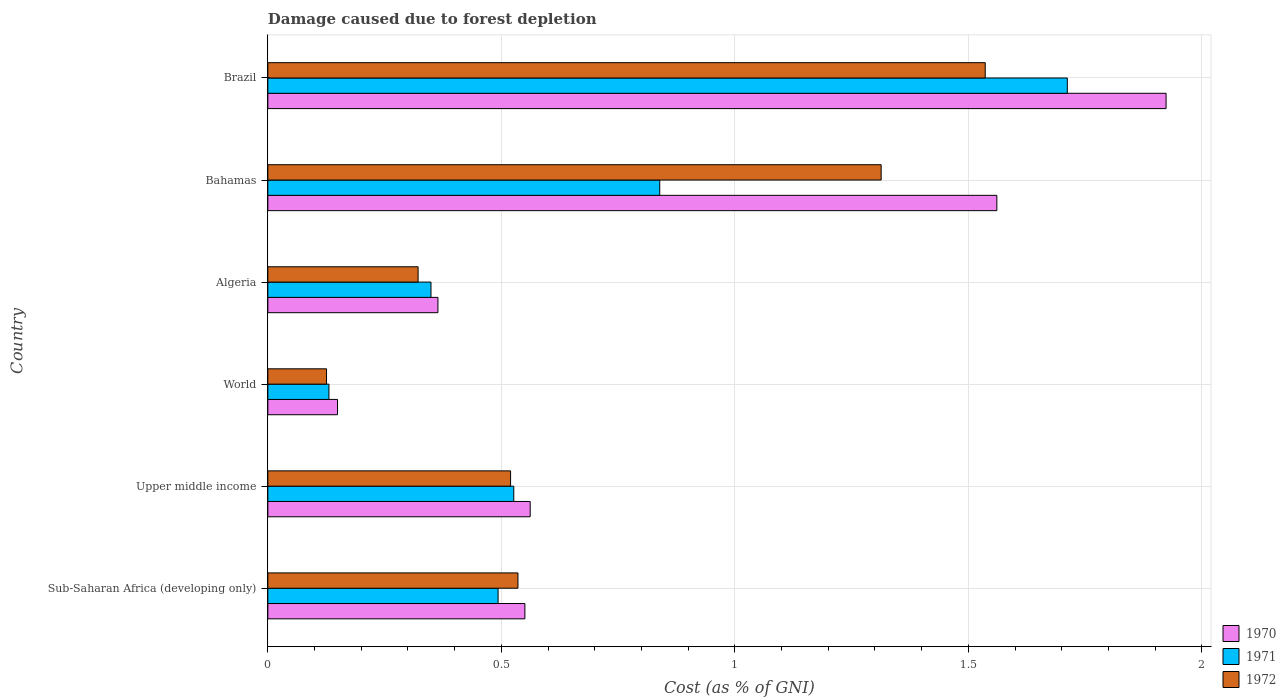Are the number of bars per tick equal to the number of legend labels?
Offer a very short reply. Yes. Are the number of bars on each tick of the Y-axis equal?
Keep it short and to the point. Yes. What is the label of the 5th group of bars from the top?
Ensure brevity in your answer.  Upper middle income. What is the cost of damage caused due to forest depletion in 1970 in Algeria?
Provide a short and direct response. 0.36. Across all countries, what is the maximum cost of damage caused due to forest depletion in 1970?
Give a very brief answer. 1.92. Across all countries, what is the minimum cost of damage caused due to forest depletion in 1972?
Offer a terse response. 0.13. In which country was the cost of damage caused due to forest depletion in 1971 minimum?
Offer a terse response. World. What is the total cost of damage caused due to forest depletion in 1971 in the graph?
Make the answer very short. 4.05. What is the difference between the cost of damage caused due to forest depletion in 1970 in Algeria and that in World?
Your answer should be very brief. 0.21. What is the difference between the cost of damage caused due to forest depletion in 1970 in Algeria and the cost of damage caused due to forest depletion in 1971 in Brazil?
Provide a succinct answer. -1.35. What is the average cost of damage caused due to forest depletion in 1970 per country?
Keep it short and to the point. 0.85. What is the difference between the cost of damage caused due to forest depletion in 1972 and cost of damage caused due to forest depletion in 1970 in Algeria?
Provide a short and direct response. -0.04. What is the ratio of the cost of damage caused due to forest depletion in 1970 in Bahamas to that in Sub-Saharan Africa (developing only)?
Offer a very short reply. 2.84. What is the difference between the highest and the second highest cost of damage caused due to forest depletion in 1972?
Your answer should be compact. 0.22. What is the difference between the highest and the lowest cost of damage caused due to forest depletion in 1972?
Your response must be concise. 1.41. In how many countries, is the cost of damage caused due to forest depletion in 1971 greater than the average cost of damage caused due to forest depletion in 1971 taken over all countries?
Your response must be concise. 2. What does the 1st bar from the top in World represents?
Your response must be concise. 1972. What does the 1st bar from the bottom in Sub-Saharan Africa (developing only) represents?
Offer a very short reply. 1970. How many countries are there in the graph?
Make the answer very short. 6. Does the graph contain grids?
Give a very brief answer. Yes. Where does the legend appear in the graph?
Offer a very short reply. Bottom right. How many legend labels are there?
Offer a terse response. 3. How are the legend labels stacked?
Keep it short and to the point. Vertical. What is the title of the graph?
Your answer should be very brief. Damage caused due to forest depletion. Does "2010" appear as one of the legend labels in the graph?
Provide a succinct answer. No. What is the label or title of the X-axis?
Offer a terse response. Cost (as % of GNI). What is the label or title of the Y-axis?
Offer a very short reply. Country. What is the Cost (as % of GNI) in 1970 in Sub-Saharan Africa (developing only)?
Your response must be concise. 0.55. What is the Cost (as % of GNI) of 1971 in Sub-Saharan Africa (developing only)?
Your answer should be compact. 0.49. What is the Cost (as % of GNI) in 1972 in Sub-Saharan Africa (developing only)?
Offer a very short reply. 0.54. What is the Cost (as % of GNI) of 1970 in Upper middle income?
Your answer should be compact. 0.56. What is the Cost (as % of GNI) of 1971 in Upper middle income?
Give a very brief answer. 0.53. What is the Cost (as % of GNI) in 1972 in Upper middle income?
Provide a short and direct response. 0.52. What is the Cost (as % of GNI) of 1970 in World?
Provide a short and direct response. 0.15. What is the Cost (as % of GNI) of 1971 in World?
Offer a terse response. 0.13. What is the Cost (as % of GNI) in 1972 in World?
Keep it short and to the point. 0.13. What is the Cost (as % of GNI) of 1970 in Algeria?
Offer a terse response. 0.36. What is the Cost (as % of GNI) of 1971 in Algeria?
Give a very brief answer. 0.35. What is the Cost (as % of GNI) of 1972 in Algeria?
Keep it short and to the point. 0.32. What is the Cost (as % of GNI) in 1970 in Bahamas?
Your response must be concise. 1.56. What is the Cost (as % of GNI) in 1971 in Bahamas?
Provide a short and direct response. 0.84. What is the Cost (as % of GNI) of 1972 in Bahamas?
Give a very brief answer. 1.31. What is the Cost (as % of GNI) of 1970 in Brazil?
Your answer should be compact. 1.92. What is the Cost (as % of GNI) in 1971 in Brazil?
Your answer should be compact. 1.71. What is the Cost (as % of GNI) in 1972 in Brazil?
Offer a terse response. 1.54. Across all countries, what is the maximum Cost (as % of GNI) in 1970?
Provide a succinct answer. 1.92. Across all countries, what is the maximum Cost (as % of GNI) in 1971?
Your answer should be very brief. 1.71. Across all countries, what is the maximum Cost (as % of GNI) in 1972?
Your response must be concise. 1.54. Across all countries, what is the minimum Cost (as % of GNI) in 1970?
Offer a very short reply. 0.15. Across all countries, what is the minimum Cost (as % of GNI) of 1971?
Make the answer very short. 0.13. Across all countries, what is the minimum Cost (as % of GNI) of 1972?
Your answer should be compact. 0.13. What is the total Cost (as % of GNI) in 1970 in the graph?
Offer a terse response. 5.11. What is the total Cost (as % of GNI) of 1971 in the graph?
Ensure brevity in your answer.  4.05. What is the total Cost (as % of GNI) in 1972 in the graph?
Offer a terse response. 4.35. What is the difference between the Cost (as % of GNI) of 1970 in Sub-Saharan Africa (developing only) and that in Upper middle income?
Give a very brief answer. -0.01. What is the difference between the Cost (as % of GNI) of 1971 in Sub-Saharan Africa (developing only) and that in Upper middle income?
Offer a very short reply. -0.03. What is the difference between the Cost (as % of GNI) in 1972 in Sub-Saharan Africa (developing only) and that in Upper middle income?
Offer a very short reply. 0.02. What is the difference between the Cost (as % of GNI) in 1970 in Sub-Saharan Africa (developing only) and that in World?
Provide a succinct answer. 0.4. What is the difference between the Cost (as % of GNI) in 1971 in Sub-Saharan Africa (developing only) and that in World?
Your answer should be compact. 0.36. What is the difference between the Cost (as % of GNI) of 1972 in Sub-Saharan Africa (developing only) and that in World?
Give a very brief answer. 0.41. What is the difference between the Cost (as % of GNI) of 1970 in Sub-Saharan Africa (developing only) and that in Algeria?
Offer a very short reply. 0.19. What is the difference between the Cost (as % of GNI) of 1971 in Sub-Saharan Africa (developing only) and that in Algeria?
Your answer should be compact. 0.14. What is the difference between the Cost (as % of GNI) in 1972 in Sub-Saharan Africa (developing only) and that in Algeria?
Make the answer very short. 0.21. What is the difference between the Cost (as % of GNI) in 1970 in Sub-Saharan Africa (developing only) and that in Bahamas?
Offer a very short reply. -1.01. What is the difference between the Cost (as % of GNI) of 1971 in Sub-Saharan Africa (developing only) and that in Bahamas?
Keep it short and to the point. -0.35. What is the difference between the Cost (as % of GNI) of 1972 in Sub-Saharan Africa (developing only) and that in Bahamas?
Make the answer very short. -0.78. What is the difference between the Cost (as % of GNI) of 1970 in Sub-Saharan Africa (developing only) and that in Brazil?
Ensure brevity in your answer.  -1.37. What is the difference between the Cost (as % of GNI) in 1971 in Sub-Saharan Africa (developing only) and that in Brazil?
Offer a very short reply. -1.22. What is the difference between the Cost (as % of GNI) of 1972 in Sub-Saharan Africa (developing only) and that in Brazil?
Keep it short and to the point. -1. What is the difference between the Cost (as % of GNI) of 1970 in Upper middle income and that in World?
Keep it short and to the point. 0.41. What is the difference between the Cost (as % of GNI) of 1971 in Upper middle income and that in World?
Offer a very short reply. 0.4. What is the difference between the Cost (as % of GNI) in 1972 in Upper middle income and that in World?
Keep it short and to the point. 0.39. What is the difference between the Cost (as % of GNI) of 1970 in Upper middle income and that in Algeria?
Ensure brevity in your answer.  0.2. What is the difference between the Cost (as % of GNI) of 1971 in Upper middle income and that in Algeria?
Offer a terse response. 0.18. What is the difference between the Cost (as % of GNI) of 1972 in Upper middle income and that in Algeria?
Give a very brief answer. 0.2. What is the difference between the Cost (as % of GNI) of 1970 in Upper middle income and that in Bahamas?
Keep it short and to the point. -1. What is the difference between the Cost (as % of GNI) in 1971 in Upper middle income and that in Bahamas?
Give a very brief answer. -0.31. What is the difference between the Cost (as % of GNI) of 1972 in Upper middle income and that in Bahamas?
Keep it short and to the point. -0.79. What is the difference between the Cost (as % of GNI) in 1970 in Upper middle income and that in Brazil?
Offer a very short reply. -1.36. What is the difference between the Cost (as % of GNI) in 1971 in Upper middle income and that in Brazil?
Provide a succinct answer. -1.19. What is the difference between the Cost (as % of GNI) in 1972 in Upper middle income and that in Brazil?
Provide a succinct answer. -1.02. What is the difference between the Cost (as % of GNI) in 1970 in World and that in Algeria?
Make the answer very short. -0.21. What is the difference between the Cost (as % of GNI) of 1971 in World and that in Algeria?
Your response must be concise. -0.22. What is the difference between the Cost (as % of GNI) of 1972 in World and that in Algeria?
Your answer should be compact. -0.2. What is the difference between the Cost (as % of GNI) of 1970 in World and that in Bahamas?
Make the answer very short. -1.41. What is the difference between the Cost (as % of GNI) in 1971 in World and that in Bahamas?
Make the answer very short. -0.71. What is the difference between the Cost (as % of GNI) of 1972 in World and that in Bahamas?
Offer a terse response. -1.19. What is the difference between the Cost (as % of GNI) of 1970 in World and that in Brazil?
Keep it short and to the point. -1.77. What is the difference between the Cost (as % of GNI) of 1971 in World and that in Brazil?
Give a very brief answer. -1.58. What is the difference between the Cost (as % of GNI) in 1972 in World and that in Brazil?
Ensure brevity in your answer.  -1.41. What is the difference between the Cost (as % of GNI) in 1970 in Algeria and that in Bahamas?
Your response must be concise. -1.2. What is the difference between the Cost (as % of GNI) of 1971 in Algeria and that in Bahamas?
Give a very brief answer. -0.49. What is the difference between the Cost (as % of GNI) in 1972 in Algeria and that in Bahamas?
Offer a terse response. -0.99. What is the difference between the Cost (as % of GNI) of 1970 in Algeria and that in Brazil?
Provide a succinct answer. -1.56. What is the difference between the Cost (as % of GNI) in 1971 in Algeria and that in Brazil?
Keep it short and to the point. -1.36. What is the difference between the Cost (as % of GNI) in 1972 in Algeria and that in Brazil?
Give a very brief answer. -1.21. What is the difference between the Cost (as % of GNI) in 1970 in Bahamas and that in Brazil?
Your answer should be compact. -0.36. What is the difference between the Cost (as % of GNI) in 1971 in Bahamas and that in Brazil?
Offer a terse response. -0.87. What is the difference between the Cost (as % of GNI) of 1972 in Bahamas and that in Brazil?
Give a very brief answer. -0.22. What is the difference between the Cost (as % of GNI) of 1970 in Sub-Saharan Africa (developing only) and the Cost (as % of GNI) of 1971 in Upper middle income?
Your answer should be very brief. 0.02. What is the difference between the Cost (as % of GNI) in 1970 in Sub-Saharan Africa (developing only) and the Cost (as % of GNI) in 1972 in Upper middle income?
Offer a terse response. 0.03. What is the difference between the Cost (as % of GNI) in 1971 in Sub-Saharan Africa (developing only) and the Cost (as % of GNI) in 1972 in Upper middle income?
Make the answer very short. -0.03. What is the difference between the Cost (as % of GNI) in 1970 in Sub-Saharan Africa (developing only) and the Cost (as % of GNI) in 1971 in World?
Ensure brevity in your answer.  0.42. What is the difference between the Cost (as % of GNI) in 1970 in Sub-Saharan Africa (developing only) and the Cost (as % of GNI) in 1972 in World?
Offer a terse response. 0.42. What is the difference between the Cost (as % of GNI) of 1971 in Sub-Saharan Africa (developing only) and the Cost (as % of GNI) of 1972 in World?
Ensure brevity in your answer.  0.37. What is the difference between the Cost (as % of GNI) of 1970 in Sub-Saharan Africa (developing only) and the Cost (as % of GNI) of 1971 in Algeria?
Keep it short and to the point. 0.2. What is the difference between the Cost (as % of GNI) in 1970 in Sub-Saharan Africa (developing only) and the Cost (as % of GNI) in 1972 in Algeria?
Your response must be concise. 0.23. What is the difference between the Cost (as % of GNI) of 1971 in Sub-Saharan Africa (developing only) and the Cost (as % of GNI) of 1972 in Algeria?
Provide a succinct answer. 0.17. What is the difference between the Cost (as % of GNI) of 1970 in Sub-Saharan Africa (developing only) and the Cost (as % of GNI) of 1971 in Bahamas?
Your answer should be very brief. -0.29. What is the difference between the Cost (as % of GNI) of 1970 in Sub-Saharan Africa (developing only) and the Cost (as % of GNI) of 1972 in Bahamas?
Make the answer very short. -0.76. What is the difference between the Cost (as % of GNI) of 1971 in Sub-Saharan Africa (developing only) and the Cost (as % of GNI) of 1972 in Bahamas?
Make the answer very short. -0.82. What is the difference between the Cost (as % of GNI) in 1970 in Sub-Saharan Africa (developing only) and the Cost (as % of GNI) in 1971 in Brazil?
Make the answer very short. -1.16. What is the difference between the Cost (as % of GNI) of 1970 in Sub-Saharan Africa (developing only) and the Cost (as % of GNI) of 1972 in Brazil?
Make the answer very short. -0.99. What is the difference between the Cost (as % of GNI) of 1971 in Sub-Saharan Africa (developing only) and the Cost (as % of GNI) of 1972 in Brazil?
Your answer should be compact. -1.04. What is the difference between the Cost (as % of GNI) in 1970 in Upper middle income and the Cost (as % of GNI) in 1971 in World?
Provide a short and direct response. 0.43. What is the difference between the Cost (as % of GNI) of 1970 in Upper middle income and the Cost (as % of GNI) of 1972 in World?
Provide a succinct answer. 0.44. What is the difference between the Cost (as % of GNI) of 1971 in Upper middle income and the Cost (as % of GNI) of 1972 in World?
Offer a terse response. 0.4. What is the difference between the Cost (as % of GNI) of 1970 in Upper middle income and the Cost (as % of GNI) of 1971 in Algeria?
Offer a terse response. 0.21. What is the difference between the Cost (as % of GNI) of 1970 in Upper middle income and the Cost (as % of GNI) of 1972 in Algeria?
Make the answer very short. 0.24. What is the difference between the Cost (as % of GNI) of 1971 in Upper middle income and the Cost (as % of GNI) of 1972 in Algeria?
Ensure brevity in your answer.  0.2. What is the difference between the Cost (as % of GNI) of 1970 in Upper middle income and the Cost (as % of GNI) of 1971 in Bahamas?
Ensure brevity in your answer.  -0.28. What is the difference between the Cost (as % of GNI) of 1970 in Upper middle income and the Cost (as % of GNI) of 1972 in Bahamas?
Make the answer very short. -0.75. What is the difference between the Cost (as % of GNI) of 1971 in Upper middle income and the Cost (as % of GNI) of 1972 in Bahamas?
Ensure brevity in your answer.  -0.79. What is the difference between the Cost (as % of GNI) of 1970 in Upper middle income and the Cost (as % of GNI) of 1971 in Brazil?
Offer a very short reply. -1.15. What is the difference between the Cost (as % of GNI) of 1970 in Upper middle income and the Cost (as % of GNI) of 1972 in Brazil?
Your answer should be very brief. -0.97. What is the difference between the Cost (as % of GNI) of 1971 in Upper middle income and the Cost (as % of GNI) of 1972 in Brazil?
Give a very brief answer. -1.01. What is the difference between the Cost (as % of GNI) in 1970 in World and the Cost (as % of GNI) in 1971 in Algeria?
Give a very brief answer. -0.2. What is the difference between the Cost (as % of GNI) in 1970 in World and the Cost (as % of GNI) in 1972 in Algeria?
Your answer should be compact. -0.17. What is the difference between the Cost (as % of GNI) of 1971 in World and the Cost (as % of GNI) of 1972 in Algeria?
Provide a short and direct response. -0.19. What is the difference between the Cost (as % of GNI) in 1970 in World and the Cost (as % of GNI) in 1971 in Bahamas?
Make the answer very short. -0.69. What is the difference between the Cost (as % of GNI) in 1970 in World and the Cost (as % of GNI) in 1972 in Bahamas?
Give a very brief answer. -1.16. What is the difference between the Cost (as % of GNI) in 1971 in World and the Cost (as % of GNI) in 1972 in Bahamas?
Ensure brevity in your answer.  -1.18. What is the difference between the Cost (as % of GNI) in 1970 in World and the Cost (as % of GNI) in 1971 in Brazil?
Your response must be concise. -1.56. What is the difference between the Cost (as % of GNI) in 1970 in World and the Cost (as % of GNI) in 1972 in Brazil?
Provide a succinct answer. -1.39. What is the difference between the Cost (as % of GNI) of 1971 in World and the Cost (as % of GNI) of 1972 in Brazil?
Give a very brief answer. -1.41. What is the difference between the Cost (as % of GNI) in 1970 in Algeria and the Cost (as % of GNI) in 1971 in Bahamas?
Make the answer very short. -0.47. What is the difference between the Cost (as % of GNI) of 1970 in Algeria and the Cost (as % of GNI) of 1972 in Bahamas?
Your response must be concise. -0.95. What is the difference between the Cost (as % of GNI) of 1971 in Algeria and the Cost (as % of GNI) of 1972 in Bahamas?
Provide a short and direct response. -0.96. What is the difference between the Cost (as % of GNI) of 1970 in Algeria and the Cost (as % of GNI) of 1971 in Brazil?
Your response must be concise. -1.35. What is the difference between the Cost (as % of GNI) in 1970 in Algeria and the Cost (as % of GNI) in 1972 in Brazil?
Give a very brief answer. -1.17. What is the difference between the Cost (as % of GNI) of 1971 in Algeria and the Cost (as % of GNI) of 1972 in Brazil?
Give a very brief answer. -1.19. What is the difference between the Cost (as % of GNI) of 1970 in Bahamas and the Cost (as % of GNI) of 1971 in Brazil?
Make the answer very short. -0.15. What is the difference between the Cost (as % of GNI) of 1970 in Bahamas and the Cost (as % of GNI) of 1972 in Brazil?
Your response must be concise. 0.02. What is the difference between the Cost (as % of GNI) of 1971 in Bahamas and the Cost (as % of GNI) of 1972 in Brazil?
Provide a succinct answer. -0.7. What is the average Cost (as % of GNI) in 1970 per country?
Offer a very short reply. 0.85. What is the average Cost (as % of GNI) of 1971 per country?
Your answer should be compact. 0.68. What is the average Cost (as % of GNI) of 1972 per country?
Make the answer very short. 0.73. What is the difference between the Cost (as % of GNI) of 1970 and Cost (as % of GNI) of 1971 in Sub-Saharan Africa (developing only)?
Provide a succinct answer. 0.06. What is the difference between the Cost (as % of GNI) in 1970 and Cost (as % of GNI) in 1972 in Sub-Saharan Africa (developing only)?
Provide a short and direct response. 0.01. What is the difference between the Cost (as % of GNI) in 1971 and Cost (as % of GNI) in 1972 in Sub-Saharan Africa (developing only)?
Provide a succinct answer. -0.04. What is the difference between the Cost (as % of GNI) in 1970 and Cost (as % of GNI) in 1971 in Upper middle income?
Offer a very short reply. 0.04. What is the difference between the Cost (as % of GNI) in 1970 and Cost (as % of GNI) in 1972 in Upper middle income?
Your response must be concise. 0.04. What is the difference between the Cost (as % of GNI) of 1971 and Cost (as % of GNI) of 1972 in Upper middle income?
Your answer should be compact. 0.01. What is the difference between the Cost (as % of GNI) in 1970 and Cost (as % of GNI) in 1971 in World?
Ensure brevity in your answer.  0.02. What is the difference between the Cost (as % of GNI) of 1970 and Cost (as % of GNI) of 1972 in World?
Offer a very short reply. 0.02. What is the difference between the Cost (as % of GNI) in 1971 and Cost (as % of GNI) in 1972 in World?
Ensure brevity in your answer.  0.01. What is the difference between the Cost (as % of GNI) of 1970 and Cost (as % of GNI) of 1971 in Algeria?
Your answer should be very brief. 0.01. What is the difference between the Cost (as % of GNI) in 1970 and Cost (as % of GNI) in 1972 in Algeria?
Your response must be concise. 0.04. What is the difference between the Cost (as % of GNI) of 1971 and Cost (as % of GNI) of 1972 in Algeria?
Your answer should be very brief. 0.03. What is the difference between the Cost (as % of GNI) in 1970 and Cost (as % of GNI) in 1971 in Bahamas?
Ensure brevity in your answer.  0.72. What is the difference between the Cost (as % of GNI) in 1970 and Cost (as % of GNI) in 1972 in Bahamas?
Your answer should be compact. 0.25. What is the difference between the Cost (as % of GNI) of 1971 and Cost (as % of GNI) of 1972 in Bahamas?
Provide a succinct answer. -0.47. What is the difference between the Cost (as % of GNI) in 1970 and Cost (as % of GNI) in 1971 in Brazil?
Ensure brevity in your answer.  0.21. What is the difference between the Cost (as % of GNI) in 1970 and Cost (as % of GNI) in 1972 in Brazil?
Keep it short and to the point. 0.39. What is the difference between the Cost (as % of GNI) of 1971 and Cost (as % of GNI) of 1972 in Brazil?
Your answer should be compact. 0.18. What is the ratio of the Cost (as % of GNI) in 1970 in Sub-Saharan Africa (developing only) to that in Upper middle income?
Your answer should be very brief. 0.98. What is the ratio of the Cost (as % of GNI) of 1971 in Sub-Saharan Africa (developing only) to that in Upper middle income?
Offer a very short reply. 0.94. What is the ratio of the Cost (as % of GNI) in 1972 in Sub-Saharan Africa (developing only) to that in Upper middle income?
Your answer should be very brief. 1.03. What is the ratio of the Cost (as % of GNI) in 1970 in Sub-Saharan Africa (developing only) to that in World?
Keep it short and to the point. 3.69. What is the ratio of the Cost (as % of GNI) of 1971 in Sub-Saharan Africa (developing only) to that in World?
Make the answer very short. 3.77. What is the ratio of the Cost (as % of GNI) in 1972 in Sub-Saharan Africa (developing only) to that in World?
Make the answer very short. 4.26. What is the ratio of the Cost (as % of GNI) of 1970 in Sub-Saharan Africa (developing only) to that in Algeria?
Keep it short and to the point. 1.51. What is the ratio of the Cost (as % of GNI) of 1971 in Sub-Saharan Africa (developing only) to that in Algeria?
Offer a terse response. 1.41. What is the ratio of the Cost (as % of GNI) in 1972 in Sub-Saharan Africa (developing only) to that in Algeria?
Provide a short and direct response. 1.66. What is the ratio of the Cost (as % of GNI) in 1970 in Sub-Saharan Africa (developing only) to that in Bahamas?
Ensure brevity in your answer.  0.35. What is the ratio of the Cost (as % of GNI) in 1971 in Sub-Saharan Africa (developing only) to that in Bahamas?
Your response must be concise. 0.59. What is the ratio of the Cost (as % of GNI) in 1972 in Sub-Saharan Africa (developing only) to that in Bahamas?
Ensure brevity in your answer.  0.41. What is the ratio of the Cost (as % of GNI) of 1970 in Sub-Saharan Africa (developing only) to that in Brazil?
Your answer should be very brief. 0.29. What is the ratio of the Cost (as % of GNI) of 1971 in Sub-Saharan Africa (developing only) to that in Brazil?
Ensure brevity in your answer.  0.29. What is the ratio of the Cost (as % of GNI) in 1972 in Sub-Saharan Africa (developing only) to that in Brazil?
Your response must be concise. 0.35. What is the ratio of the Cost (as % of GNI) of 1970 in Upper middle income to that in World?
Your answer should be compact. 3.76. What is the ratio of the Cost (as % of GNI) of 1971 in Upper middle income to that in World?
Ensure brevity in your answer.  4.03. What is the ratio of the Cost (as % of GNI) of 1972 in Upper middle income to that in World?
Your answer should be very brief. 4.14. What is the ratio of the Cost (as % of GNI) in 1970 in Upper middle income to that in Algeria?
Provide a succinct answer. 1.54. What is the ratio of the Cost (as % of GNI) in 1971 in Upper middle income to that in Algeria?
Your answer should be compact. 1.51. What is the ratio of the Cost (as % of GNI) of 1972 in Upper middle income to that in Algeria?
Offer a very short reply. 1.62. What is the ratio of the Cost (as % of GNI) of 1970 in Upper middle income to that in Bahamas?
Your response must be concise. 0.36. What is the ratio of the Cost (as % of GNI) of 1971 in Upper middle income to that in Bahamas?
Provide a succinct answer. 0.63. What is the ratio of the Cost (as % of GNI) of 1972 in Upper middle income to that in Bahamas?
Your answer should be compact. 0.4. What is the ratio of the Cost (as % of GNI) in 1970 in Upper middle income to that in Brazil?
Give a very brief answer. 0.29. What is the ratio of the Cost (as % of GNI) in 1971 in Upper middle income to that in Brazil?
Ensure brevity in your answer.  0.31. What is the ratio of the Cost (as % of GNI) in 1972 in Upper middle income to that in Brazil?
Make the answer very short. 0.34. What is the ratio of the Cost (as % of GNI) of 1970 in World to that in Algeria?
Your answer should be very brief. 0.41. What is the ratio of the Cost (as % of GNI) of 1971 in World to that in Algeria?
Offer a very short reply. 0.37. What is the ratio of the Cost (as % of GNI) in 1972 in World to that in Algeria?
Provide a short and direct response. 0.39. What is the ratio of the Cost (as % of GNI) in 1970 in World to that in Bahamas?
Keep it short and to the point. 0.1. What is the ratio of the Cost (as % of GNI) of 1971 in World to that in Bahamas?
Provide a succinct answer. 0.16. What is the ratio of the Cost (as % of GNI) of 1972 in World to that in Bahamas?
Give a very brief answer. 0.1. What is the ratio of the Cost (as % of GNI) of 1970 in World to that in Brazil?
Your answer should be very brief. 0.08. What is the ratio of the Cost (as % of GNI) of 1971 in World to that in Brazil?
Offer a terse response. 0.08. What is the ratio of the Cost (as % of GNI) in 1972 in World to that in Brazil?
Offer a very short reply. 0.08. What is the ratio of the Cost (as % of GNI) of 1970 in Algeria to that in Bahamas?
Make the answer very short. 0.23. What is the ratio of the Cost (as % of GNI) in 1971 in Algeria to that in Bahamas?
Ensure brevity in your answer.  0.42. What is the ratio of the Cost (as % of GNI) of 1972 in Algeria to that in Bahamas?
Your answer should be compact. 0.24. What is the ratio of the Cost (as % of GNI) of 1970 in Algeria to that in Brazil?
Ensure brevity in your answer.  0.19. What is the ratio of the Cost (as % of GNI) of 1971 in Algeria to that in Brazil?
Make the answer very short. 0.2. What is the ratio of the Cost (as % of GNI) of 1972 in Algeria to that in Brazil?
Your response must be concise. 0.21. What is the ratio of the Cost (as % of GNI) in 1970 in Bahamas to that in Brazil?
Provide a succinct answer. 0.81. What is the ratio of the Cost (as % of GNI) in 1971 in Bahamas to that in Brazil?
Provide a short and direct response. 0.49. What is the ratio of the Cost (as % of GNI) of 1972 in Bahamas to that in Brazil?
Give a very brief answer. 0.85. What is the difference between the highest and the second highest Cost (as % of GNI) in 1970?
Offer a terse response. 0.36. What is the difference between the highest and the second highest Cost (as % of GNI) of 1971?
Your response must be concise. 0.87. What is the difference between the highest and the second highest Cost (as % of GNI) of 1972?
Offer a terse response. 0.22. What is the difference between the highest and the lowest Cost (as % of GNI) of 1970?
Your answer should be compact. 1.77. What is the difference between the highest and the lowest Cost (as % of GNI) of 1971?
Provide a succinct answer. 1.58. What is the difference between the highest and the lowest Cost (as % of GNI) of 1972?
Your response must be concise. 1.41. 